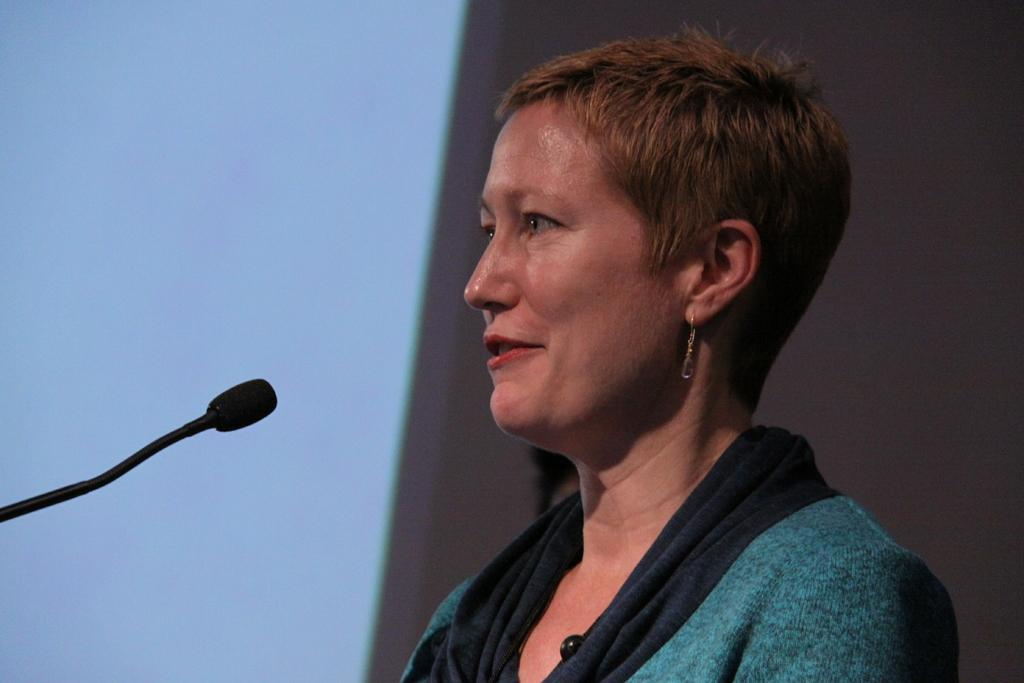Who is present in the image? There is a lady in the image. What can be seen on the left side of the image? There is a mic on the left side of the image. What is visible in the background of the image? There is a wall in the background of the image. What is the purpose of the screen in the image? The purpose of the screen is not specified, but it is present in the image. What type of apparatus is the deer using to communicate in the image? There is no deer present in the image, and therefore no such apparatus or communication can be observed. 